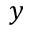Convert formula to latex. <formula><loc_0><loc_0><loc_500><loc_500>y</formula> 